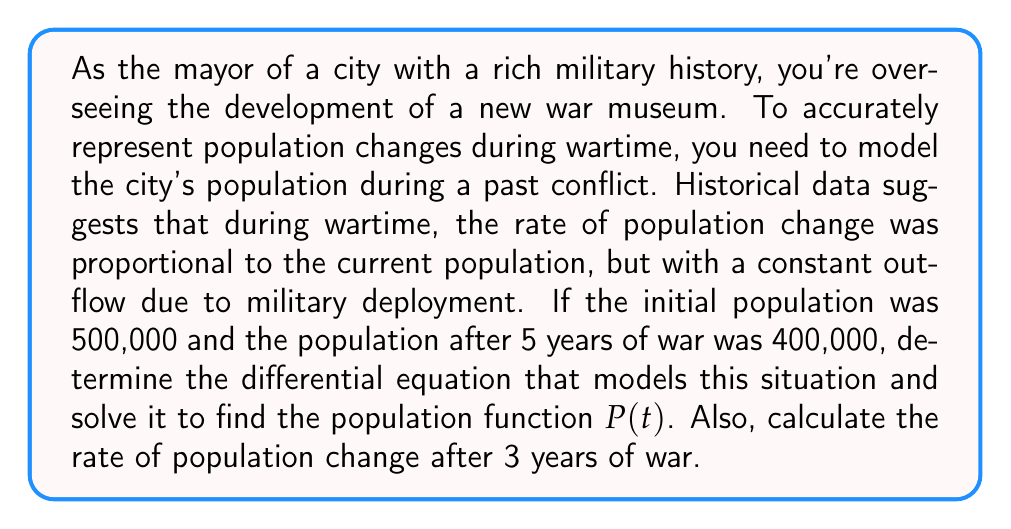Provide a solution to this math problem. Let's approach this step-by-step:

1) Let $P(t)$ be the population at time $t$ (in years). The rate of change of population is given by $\frac{dP}{dt}$.

2) We're told that the rate of change is proportional to the current population (let's call this constant of proportionality $k$), but with a constant outflow (let's call this $c$). This gives us the differential equation:

   $$\frac{dP}{dt} = kP - c$$

3) This is a linear first-order differential equation. The general solution is:

   $$P(t) = Ce^{kt} + \frac{c}{k}$$

   where $C$ is a constant we need to determine.

4) We know two points: 
   At $t=0$, $P(0) = 500,000$
   At $t=5$, $P(5) = 400,000$

5) Using the initial condition:
   
   $500,000 = C + \frac{c}{k}$

6) Using the condition at $t=5$:

   $400,000 = Ce^{5k} + \frac{c}{k}$

7) Subtracting these equations:

   $-100,000 = C(e^{5k} - 1)$

8) Dividing the equations:

   $\frac{400,000}{500,000} = \frac{Ce^{5k} + \frac{c}{k}}{C + \frac{c}{k}} = 0.8$

9) This gives us:

   $e^{5k} = 0.75$

10) Solving for $k$:

    $k = \frac{\ln(0.75)}{5} \approx -0.0576$

11) Now we can find $C$:

    $C = \frac{-100,000}{e^{5k} - 1} \approx 434,783$

12) And finally, $c$:

    $c = -k(500,000 - C) \approx 3,760$

13) Therefore, our population function is:

    $$P(t) = 434,783e^{-0.0576t} + 65,217$$

14) To find the rate of change after 3 years, we substitute $t=3$ into the derivative of $P(t)$:

    $$\frac{dP}{dt}(3) = -0.0576(434,783e^{-0.0576(3)}) = -21,718$$
Answer: The population function is $P(t) = 434,783e^{-0.0576t} + 65,217$, and the rate of population change after 3 years of war is approximately -21,718 people per year. 